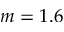<formula> <loc_0><loc_0><loc_500><loc_500>m = 1 . 6</formula> 